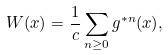Convert formula to latex. <formula><loc_0><loc_0><loc_500><loc_500>W ( x ) = \frac { 1 } { c } \sum _ { n \geq 0 } g ^ { * n } ( x ) ,</formula> 